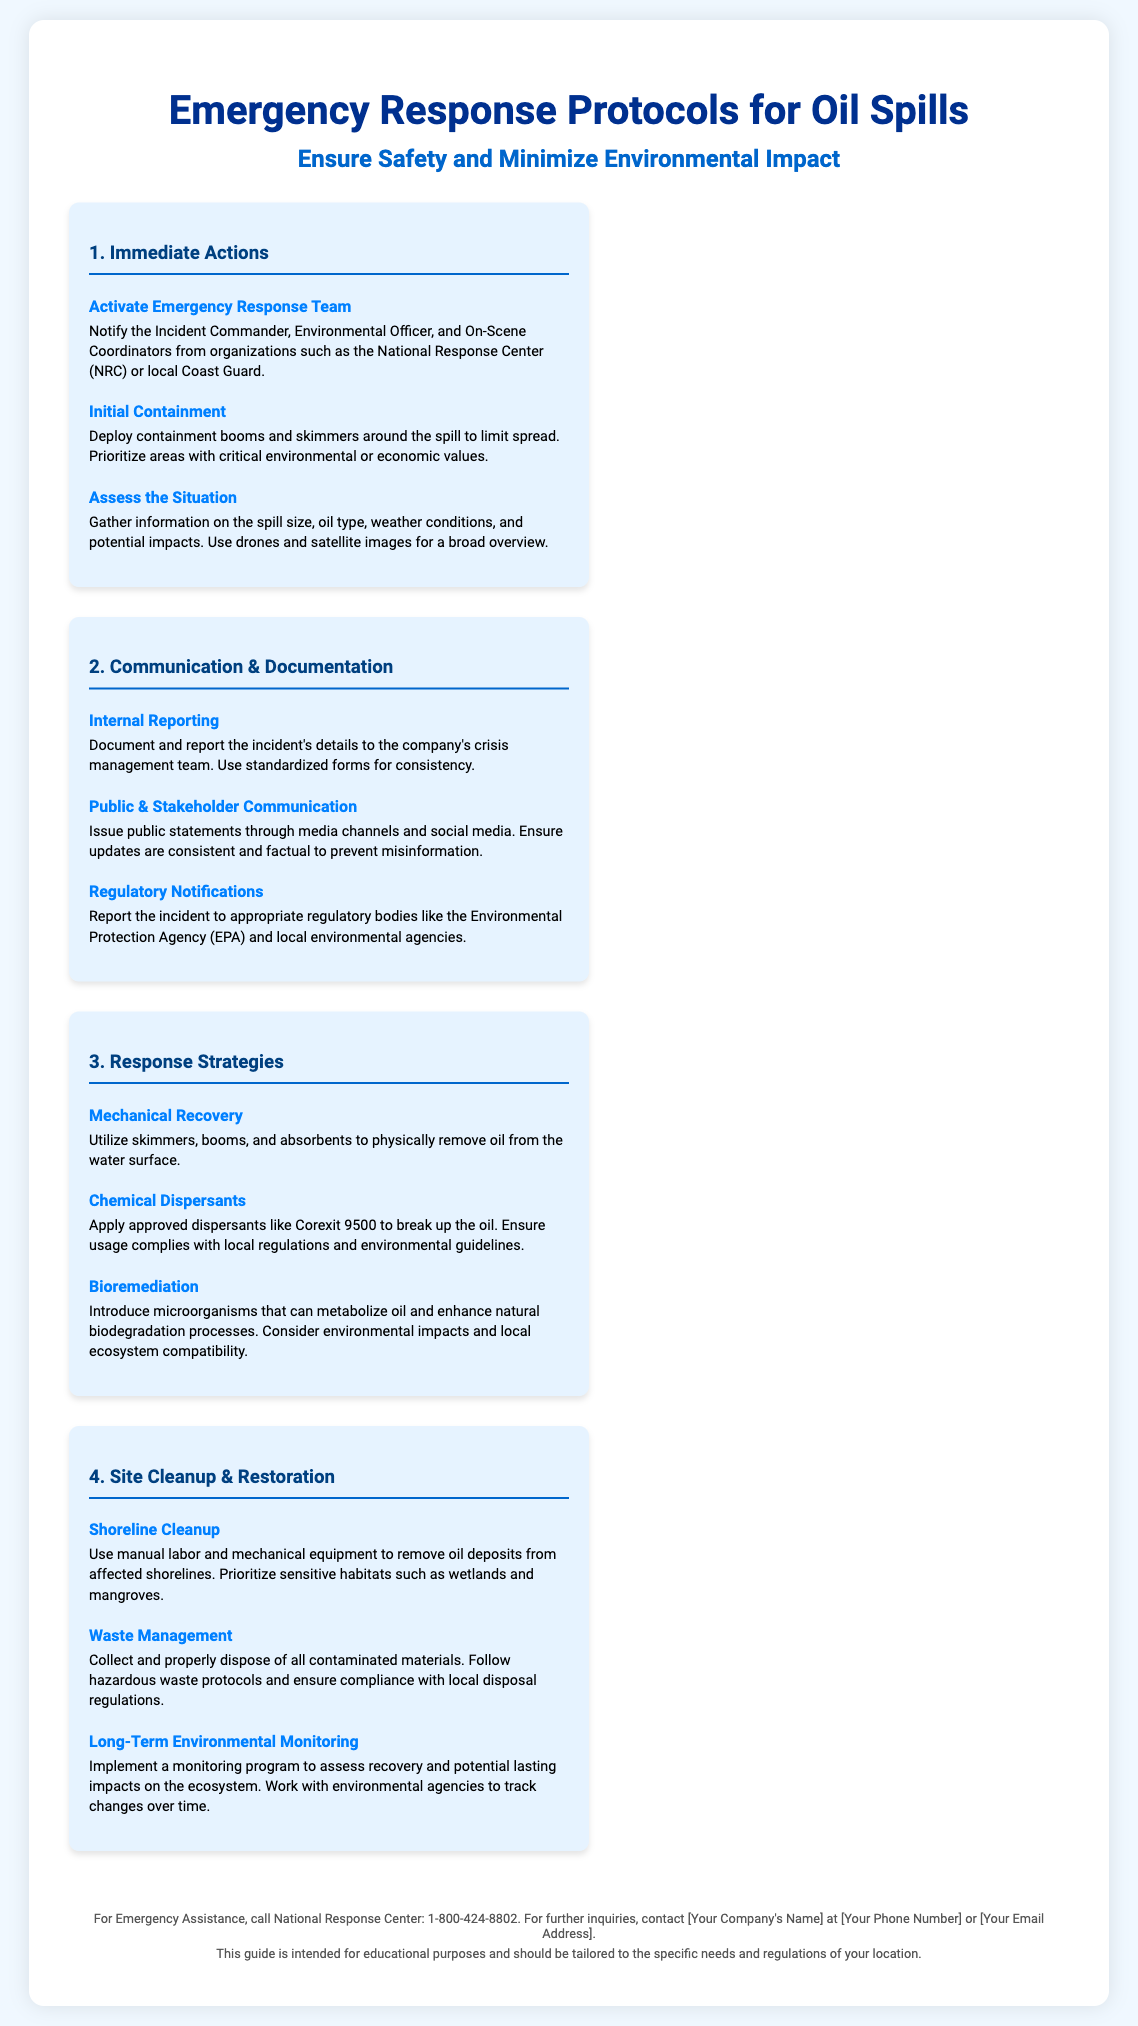What is the title of the poster? The title of the poster is prominently displayed at the top and indicates its main topic.
Answer: Emergency Response Protocols for Oil Spills Who should be notified first in an emergency response? The document outlines which key personnel should be activated in the emergency response team.
Answer: Incident Commander What is the first step in the Immediate Actions section? The first action listed under Immediate Actions provides a guideline for initial procedures during an oil spill.
Answer: Activate Emergency Response Team What type of recovery involves using absorbents? The document mentions various response strategies that describe physical removal methods of oil from the water.
Answer: Mechanical Recovery What should be reported to regulatory bodies? The document provides specific information regarding reporting obligations to regulatory institutions in case of oil spills.
Answer: The incident Which chemical dispersant is mentioned? The section on chemical dispersants specifies an example of an approved dispersant for breaking up oil.
Answer: Corexit 9500 What does the Shoreline Cleanup section prioritize? The document highlights important factors that should be taken into account during the cleanup phase.
Answer: Sensitive habitats What is the purpose of long-term environmental monitoring? The document explains the significance of monitoring programs after an oil spill recovery.
Answer: Assess recovery What is the contact number for the National Response Center? The footer of the poster includes contact information for emergency assistance.
Answer: 1-800-424-8802 